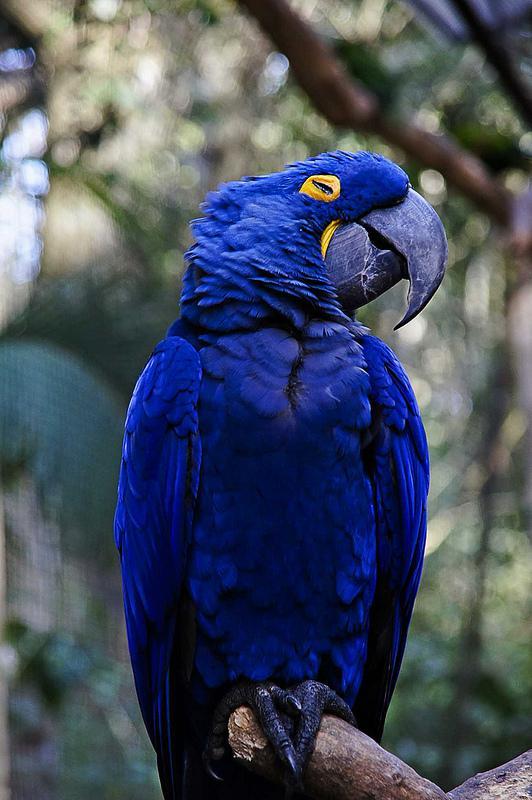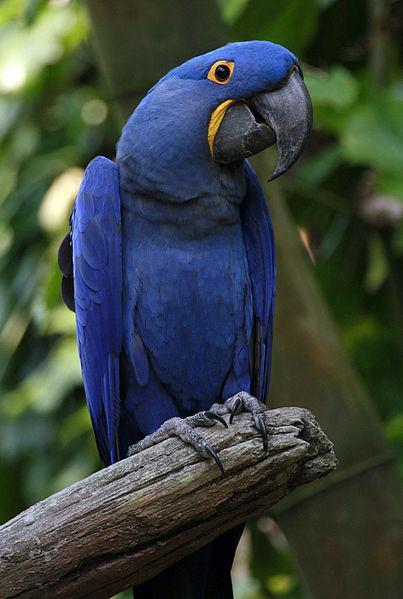The first image is the image on the left, the second image is the image on the right. Examine the images to the left and right. Is the description "Two birds sit on a branch in the image on the right." accurate? Answer yes or no. No. The first image is the image on the left, the second image is the image on the right. Assess this claim about the two images: "An image includes blue parrots with bright yellow chests.". Correct or not? Answer yes or no. No. 